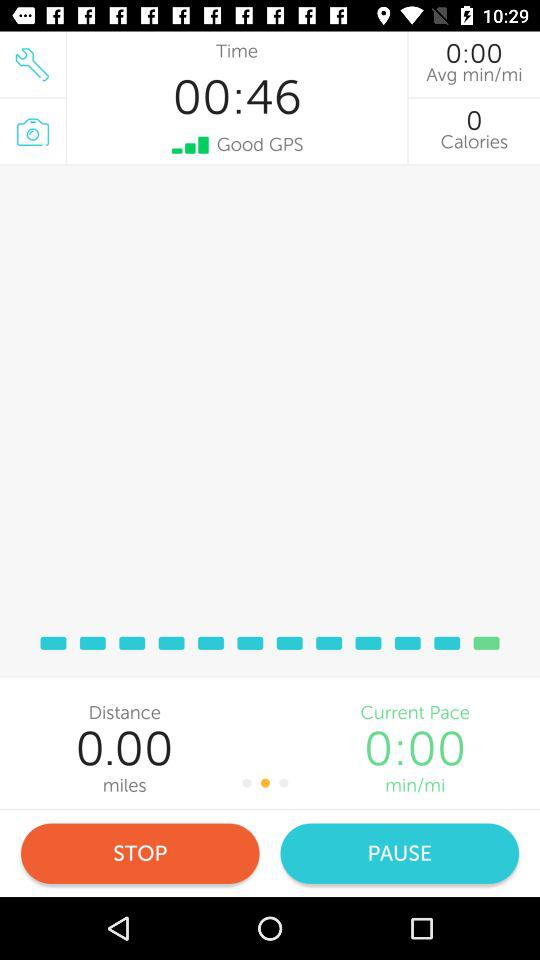How long has the user been running?
Answer the question using a single word or phrase. 00:46 